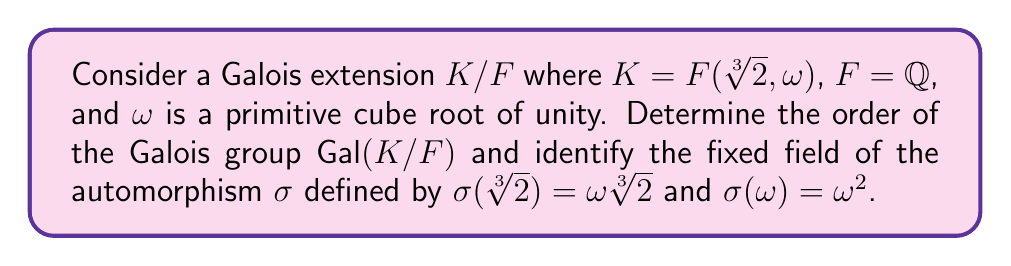What is the answer to this math problem? 1. First, let's determine the degree of the extension $K/F$:
   - $[\mathbb{Q}(\sqrt[3]{2}):\mathbb{Q}] = 3$
   - $[\mathbb{Q}(\omega):\mathbb{Q}] = 2$
   - $K = \mathbb{Q}(\sqrt[3]{2}, \omega)$, so $[K:F] = [K:\mathbb{Q}] = 6$

2. Since $K/F$ is a Galois extension, we know that $|\text{Gal}(K/F)| = [K:F] = 6$.

3. To find the fixed field of $\sigma$, we need to determine which elements of $K$ are left unchanged by $\sigma$.

4. Let $x = a + b\sqrt[3]{2} + c\sqrt[3]{4} + d\omega + e\omega\sqrt[3]{2} + f\omega\sqrt[3]{4}$ be a general element of $K$, where $a,b,c,d,e,f \in \mathbb{Q}$.

5. Apply $\sigma$ to $x$:
   $$\sigma(x) = a + b\omega\sqrt[3]{2} + c\omega^2\sqrt[3]{4} + d\omega^2 + e\omega^2\sqrt[3]{2} + f\sqrt[3]{4}$$

6. For $x$ to be in the fixed field, we must have $\sigma(x) = x$. Comparing coefficients:
   - $a = a$
   - $b\omega = b$
   - $c\omega^2 = c$
   - $d\omega^2 = d$
   - $e\omega^2 = e$
   - $f = f$

7. From these equations, we can conclude that $b = c = d = e = 0$, while $a$ and $f$ can be any rational numbers.

8. Therefore, the fixed field of $\sigma$ is $\mathbb{Q}(\sqrt[3]{4}) = \mathbb{Q}(\sqrt[3]{2})$.
Answer: $|\text{Gal}(K/F)| = 6$, Fixed field of $\sigma$: $\mathbb{Q}(\sqrt[3]{2})$ 